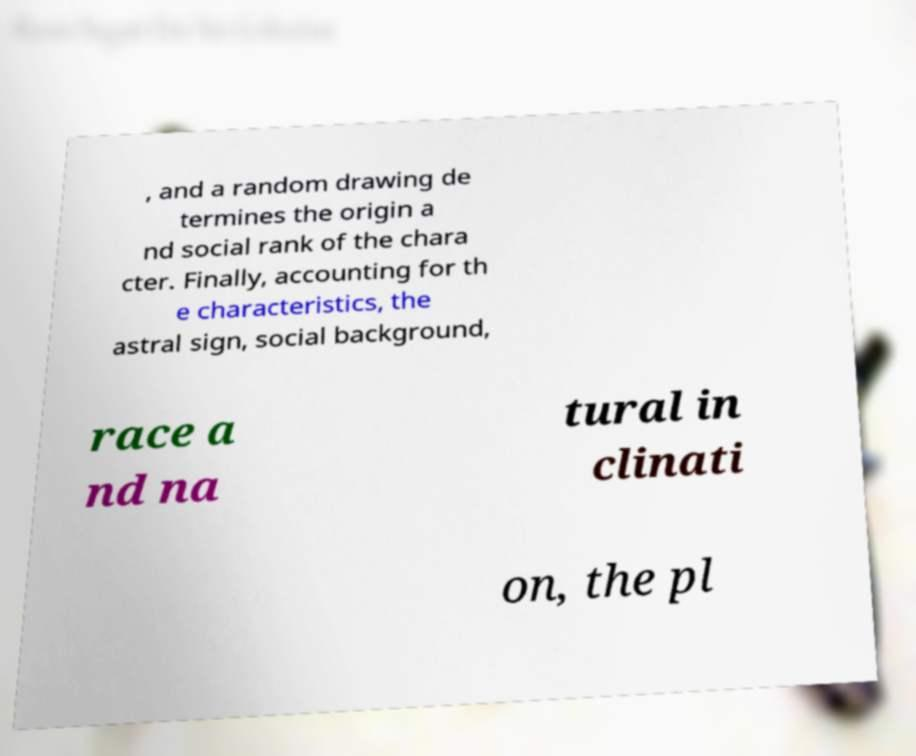Can you read and provide the text displayed in the image?This photo seems to have some interesting text. Can you extract and type it out for me? , and a random drawing de termines the origin a nd social rank of the chara cter. Finally, accounting for th e characteristics, the astral sign, social background, race a nd na tural in clinati on, the pl 